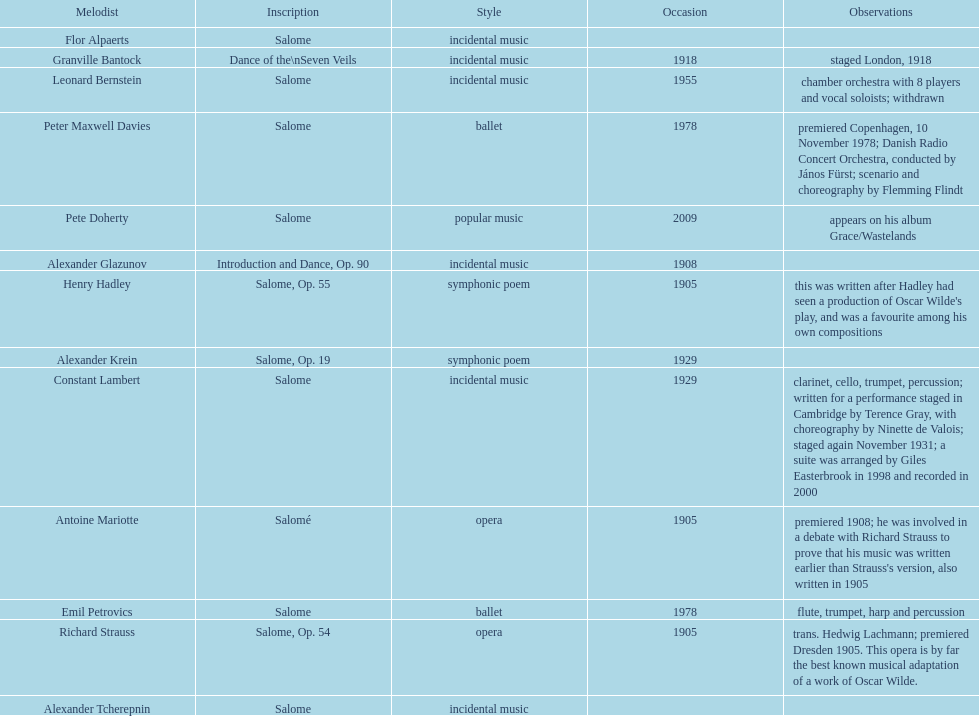What is the difference in years of granville bantock's work compared to pete dohert? 91. 